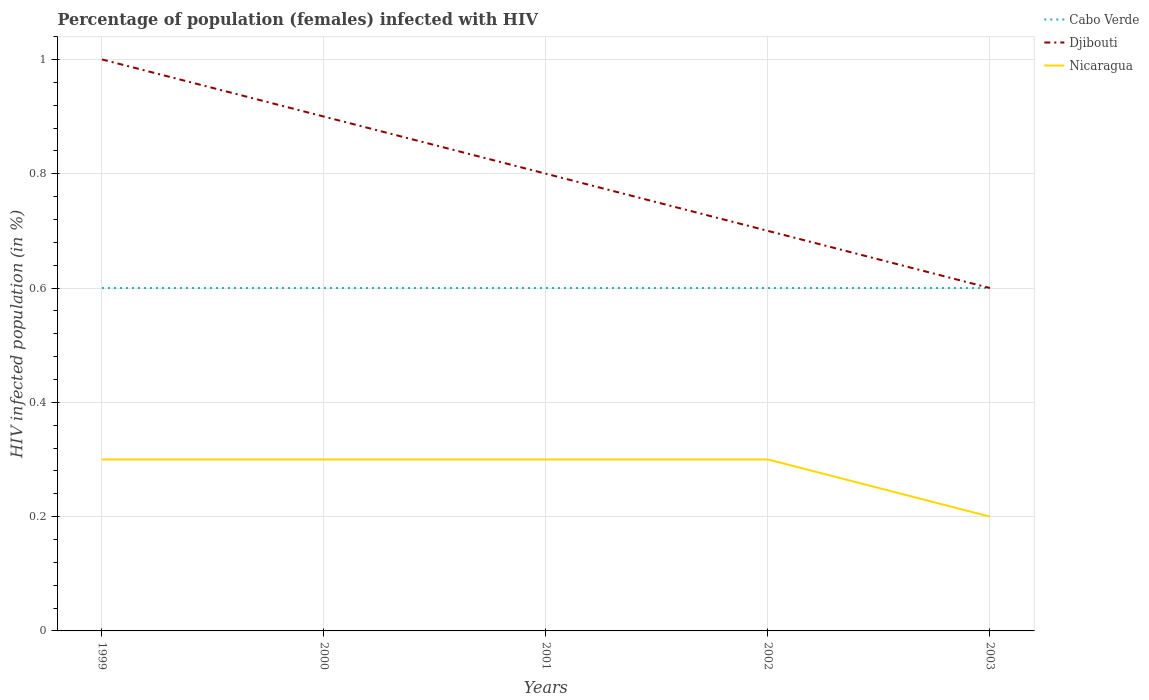Does the line corresponding to Cabo Verde intersect with the line corresponding to Nicaragua?
Your answer should be compact. No. Across all years, what is the maximum percentage of HIV infected female population in Cabo Verde?
Your answer should be compact. 0.6. In which year was the percentage of HIV infected female population in Cabo Verde maximum?
Give a very brief answer. 1999. What is the total percentage of HIV infected female population in Cabo Verde in the graph?
Ensure brevity in your answer.  0. Is the percentage of HIV infected female population in Nicaragua strictly greater than the percentage of HIV infected female population in Cabo Verde over the years?
Offer a terse response. Yes. What is the difference between two consecutive major ticks on the Y-axis?
Your answer should be very brief. 0.2. Are the values on the major ticks of Y-axis written in scientific E-notation?
Provide a succinct answer. No. Does the graph contain any zero values?
Make the answer very short. No. Where does the legend appear in the graph?
Ensure brevity in your answer.  Top right. What is the title of the graph?
Provide a short and direct response. Percentage of population (females) infected with HIV. What is the label or title of the Y-axis?
Offer a terse response. HIV infected population (in %). What is the HIV infected population (in %) in Cabo Verde in 1999?
Give a very brief answer. 0.6. What is the HIV infected population (in %) in Nicaragua in 1999?
Your answer should be compact. 0.3. What is the HIV infected population (in %) in Djibouti in 2000?
Offer a very short reply. 0.9. What is the HIV infected population (in %) of Nicaragua in 2000?
Your response must be concise. 0.3. What is the HIV infected population (in %) of Cabo Verde in 2001?
Provide a succinct answer. 0.6. What is the HIV infected population (in %) of Nicaragua in 2001?
Provide a short and direct response. 0.3. What is the HIV infected population (in %) in Cabo Verde in 2002?
Your response must be concise. 0.6. What is the HIV infected population (in %) in Djibouti in 2002?
Give a very brief answer. 0.7. What is the HIV infected population (in %) in Nicaragua in 2002?
Make the answer very short. 0.3. What is the HIV infected population (in %) of Nicaragua in 2003?
Ensure brevity in your answer.  0.2. Across all years, what is the maximum HIV infected population (in %) in Cabo Verde?
Provide a short and direct response. 0.6. Across all years, what is the minimum HIV infected population (in %) of Cabo Verde?
Provide a short and direct response. 0.6. Across all years, what is the minimum HIV infected population (in %) of Djibouti?
Give a very brief answer. 0.6. What is the total HIV infected population (in %) in Djibouti in the graph?
Give a very brief answer. 4. What is the difference between the HIV infected population (in %) of Djibouti in 1999 and that in 2000?
Ensure brevity in your answer.  0.1. What is the difference between the HIV infected population (in %) of Nicaragua in 1999 and that in 2000?
Offer a terse response. 0. What is the difference between the HIV infected population (in %) in Djibouti in 1999 and that in 2001?
Give a very brief answer. 0.2. What is the difference between the HIV infected population (in %) in Nicaragua in 1999 and that in 2001?
Offer a very short reply. 0. What is the difference between the HIV infected population (in %) of Djibouti in 1999 and that in 2002?
Give a very brief answer. 0.3. What is the difference between the HIV infected population (in %) of Cabo Verde in 1999 and that in 2003?
Keep it short and to the point. 0. What is the difference between the HIV infected population (in %) of Djibouti in 1999 and that in 2003?
Offer a terse response. 0.4. What is the difference between the HIV infected population (in %) of Djibouti in 2000 and that in 2001?
Ensure brevity in your answer.  0.1. What is the difference between the HIV infected population (in %) of Nicaragua in 2000 and that in 2002?
Keep it short and to the point. 0. What is the difference between the HIV infected population (in %) of Cabo Verde in 2000 and that in 2003?
Make the answer very short. 0. What is the difference between the HIV infected population (in %) in Djibouti in 2000 and that in 2003?
Offer a very short reply. 0.3. What is the difference between the HIV infected population (in %) of Nicaragua in 2001 and that in 2002?
Provide a succinct answer. 0. What is the difference between the HIV infected population (in %) in Cabo Verde in 2001 and that in 2003?
Give a very brief answer. 0. What is the difference between the HIV infected population (in %) in Nicaragua in 2001 and that in 2003?
Your response must be concise. 0.1. What is the difference between the HIV infected population (in %) in Djibouti in 2002 and that in 2003?
Give a very brief answer. 0.1. What is the difference between the HIV infected population (in %) of Nicaragua in 2002 and that in 2003?
Give a very brief answer. 0.1. What is the difference between the HIV infected population (in %) of Djibouti in 1999 and the HIV infected population (in %) of Nicaragua in 2000?
Your response must be concise. 0.7. What is the difference between the HIV infected population (in %) in Cabo Verde in 1999 and the HIV infected population (in %) in Djibouti in 2001?
Your response must be concise. -0.2. What is the difference between the HIV infected population (in %) in Djibouti in 1999 and the HIV infected population (in %) in Nicaragua in 2001?
Provide a succinct answer. 0.7. What is the difference between the HIV infected population (in %) of Cabo Verde in 1999 and the HIV infected population (in %) of Djibouti in 2002?
Your answer should be compact. -0.1. What is the difference between the HIV infected population (in %) of Djibouti in 1999 and the HIV infected population (in %) of Nicaragua in 2002?
Keep it short and to the point. 0.7. What is the difference between the HIV infected population (in %) in Cabo Verde in 1999 and the HIV infected population (in %) in Nicaragua in 2003?
Keep it short and to the point. 0.4. What is the difference between the HIV infected population (in %) in Djibouti in 1999 and the HIV infected population (in %) in Nicaragua in 2003?
Ensure brevity in your answer.  0.8. What is the difference between the HIV infected population (in %) of Cabo Verde in 2000 and the HIV infected population (in %) of Djibouti in 2001?
Your answer should be compact. -0.2. What is the difference between the HIV infected population (in %) of Cabo Verde in 2000 and the HIV infected population (in %) of Nicaragua in 2001?
Make the answer very short. 0.3. What is the difference between the HIV infected population (in %) in Cabo Verde in 2000 and the HIV infected population (in %) in Nicaragua in 2002?
Offer a very short reply. 0.3. What is the difference between the HIV infected population (in %) in Cabo Verde in 2000 and the HIV infected population (in %) in Djibouti in 2003?
Provide a succinct answer. 0. What is the difference between the HIV infected population (in %) of Djibouti in 2000 and the HIV infected population (in %) of Nicaragua in 2003?
Make the answer very short. 0.7. What is the difference between the HIV infected population (in %) in Cabo Verde in 2001 and the HIV infected population (in %) in Djibouti in 2003?
Offer a terse response. 0. What is the difference between the HIV infected population (in %) in Djibouti in 2001 and the HIV infected population (in %) in Nicaragua in 2003?
Your response must be concise. 0.6. What is the difference between the HIV infected population (in %) of Cabo Verde in 2002 and the HIV infected population (in %) of Djibouti in 2003?
Provide a succinct answer. 0. What is the difference between the HIV infected population (in %) of Djibouti in 2002 and the HIV infected population (in %) of Nicaragua in 2003?
Give a very brief answer. 0.5. What is the average HIV infected population (in %) in Nicaragua per year?
Give a very brief answer. 0.28. In the year 1999, what is the difference between the HIV infected population (in %) of Djibouti and HIV infected population (in %) of Nicaragua?
Provide a short and direct response. 0.7. In the year 2000, what is the difference between the HIV infected population (in %) in Cabo Verde and HIV infected population (in %) in Djibouti?
Offer a terse response. -0.3. In the year 2000, what is the difference between the HIV infected population (in %) of Cabo Verde and HIV infected population (in %) of Nicaragua?
Give a very brief answer. 0.3. In the year 2000, what is the difference between the HIV infected population (in %) in Djibouti and HIV infected population (in %) in Nicaragua?
Your answer should be compact. 0.6. In the year 2001, what is the difference between the HIV infected population (in %) in Djibouti and HIV infected population (in %) in Nicaragua?
Your response must be concise. 0.5. In the year 2003, what is the difference between the HIV infected population (in %) of Cabo Verde and HIV infected population (in %) of Nicaragua?
Ensure brevity in your answer.  0.4. In the year 2003, what is the difference between the HIV infected population (in %) of Djibouti and HIV infected population (in %) of Nicaragua?
Offer a terse response. 0.4. What is the ratio of the HIV infected population (in %) in Djibouti in 1999 to that in 2000?
Offer a terse response. 1.11. What is the ratio of the HIV infected population (in %) in Cabo Verde in 1999 to that in 2001?
Make the answer very short. 1. What is the ratio of the HIV infected population (in %) of Djibouti in 1999 to that in 2002?
Give a very brief answer. 1.43. What is the ratio of the HIV infected population (in %) of Djibouti in 1999 to that in 2003?
Your answer should be compact. 1.67. What is the ratio of the HIV infected population (in %) of Cabo Verde in 2000 to that in 2001?
Your answer should be very brief. 1. What is the ratio of the HIV infected population (in %) in Djibouti in 2000 to that in 2002?
Make the answer very short. 1.29. What is the ratio of the HIV infected population (in %) in Cabo Verde in 2000 to that in 2003?
Keep it short and to the point. 1. What is the ratio of the HIV infected population (in %) of Nicaragua in 2000 to that in 2003?
Provide a short and direct response. 1.5. What is the ratio of the HIV infected population (in %) in Cabo Verde in 2001 to that in 2002?
Provide a short and direct response. 1. What is the ratio of the HIV infected population (in %) in Djibouti in 2001 to that in 2002?
Provide a short and direct response. 1.14. What is the ratio of the HIV infected population (in %) of Nicaragua in 2001 to that in 2002?
Your response must be concise. 1. What is the ratio of the HIV infected population (in %) in Djibouti in 2001 to that in 2003?
Give a very brief answer. 1.33. What is the ratio of the HIV infected population (in %) in Nicaragua in 2001 to that in 2003?
Ensure brevity in your answer.  1.5. What is the ratio of the HIV infected population (in %) in Cabo Verde in 2002 to that in 2003?
Make the answer very short. 1. What is the difference between the highest and the second highest HIV infected population (in %) in Djibouti?
Offer a terse response. 0.1. What is the difference between the highest and the second highest HIV infected population (in %) in Nicaragua?
Your response must be concise. 0. What is the difference between the highest and the lowest HIV infected population (in %) of Cabo Verde?
Make the answer very short. 0. What is the difference between the highest and the lowest HIV infected population (in %) in Djibouti?
Keep it short and to the point. 0.4. What is the difference between the highest and the lowest HIV infected population (in %) in Nicaragua?
Keep it short and to the point. 0.1. 